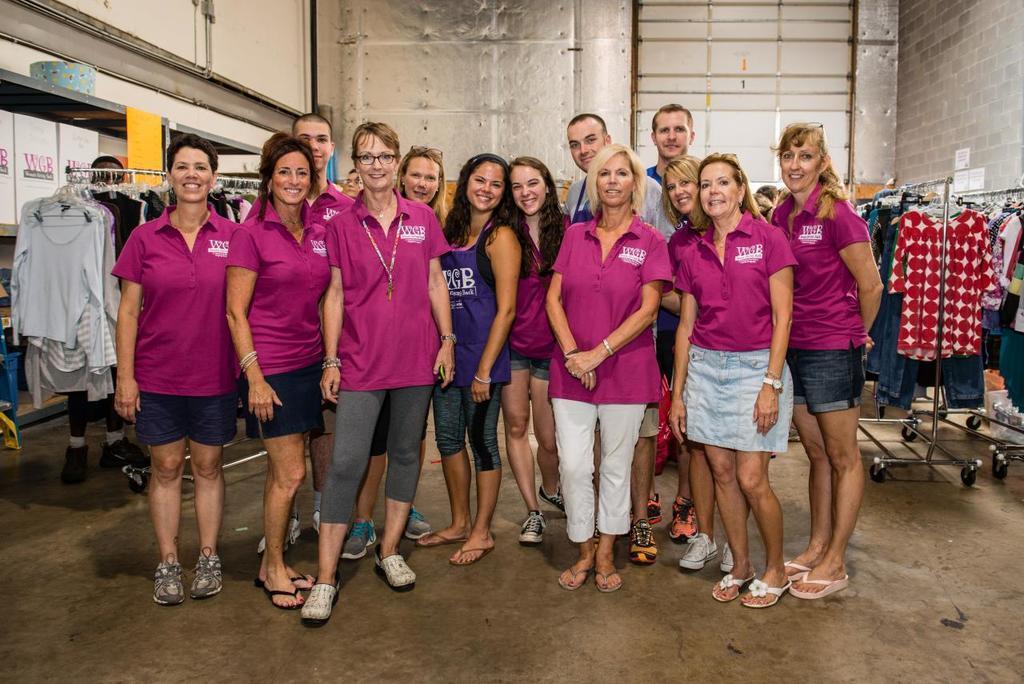Describe this image in one or two sentences. In this image there is a group of people standing with a smile on their face are posing for the camera, besides them there are clothes on the hangers, behind the hanger there is a person standing, in the background of the image there is a wall. 